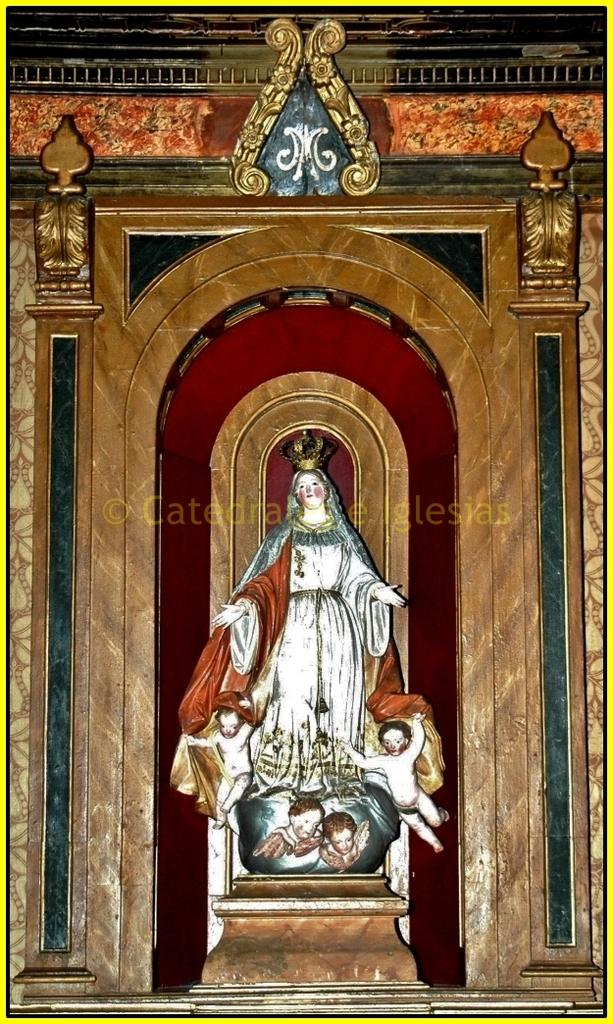Where was the image taken? The image was taken in a church. What is the main subject in the middle of the image? There is a statue in the middle of the image. What can be seen in the background of the image? There is an architectural feature in the background of the image. What type of cabbage is being used as a decoration in the image? There is no cabbage present in the image; it is taken in a church and features a statue and an architectural feature in the background. 